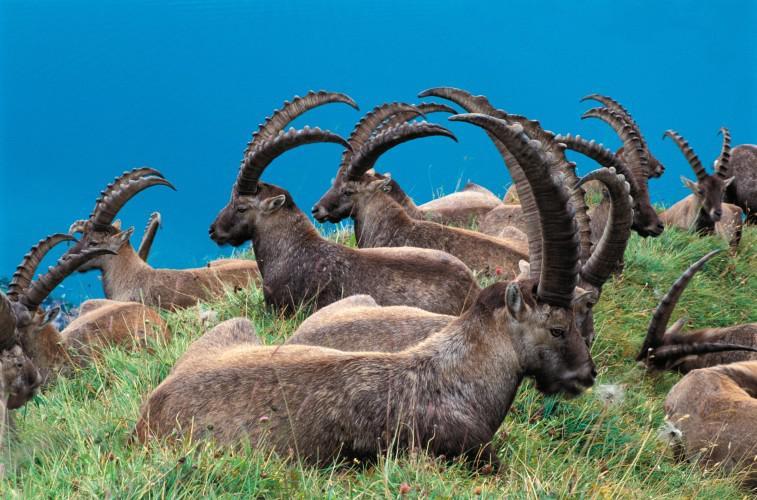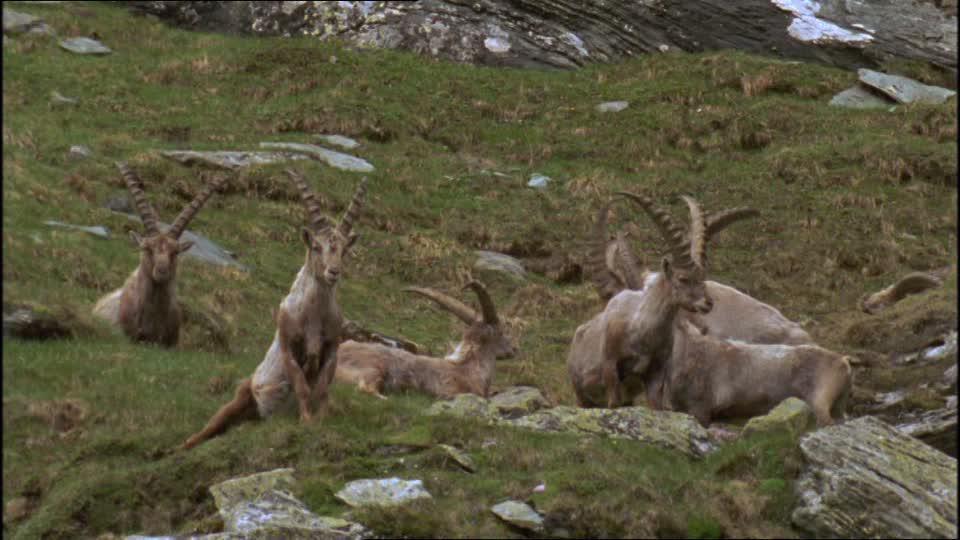The first image is the image on the left, the second image is the image on the right. Examine the images to the left and right. Is the description "There is only one antelope in one of the images" accurate? Answer yes or no. No. The first image is the image on the left, the second image is the image on the right. Considering the images on both sides, is "An image shows no more than two goats standing on a rock peak." valid? Answer yes or no. No. The first image is the image on the left, the second image is the image on the right. Evaluate the accuracy of this statement regarding the images: "At least one of the animals is standing on a boulder in one of the images.". Is it true? Answer yes or no. No. 